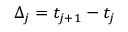Convert formula to latex. <formula><loc_0><loc_0><loc_500><loc_500>\Delta _ { j } = t _ { j + 1 } - t _ { j }</formula> 